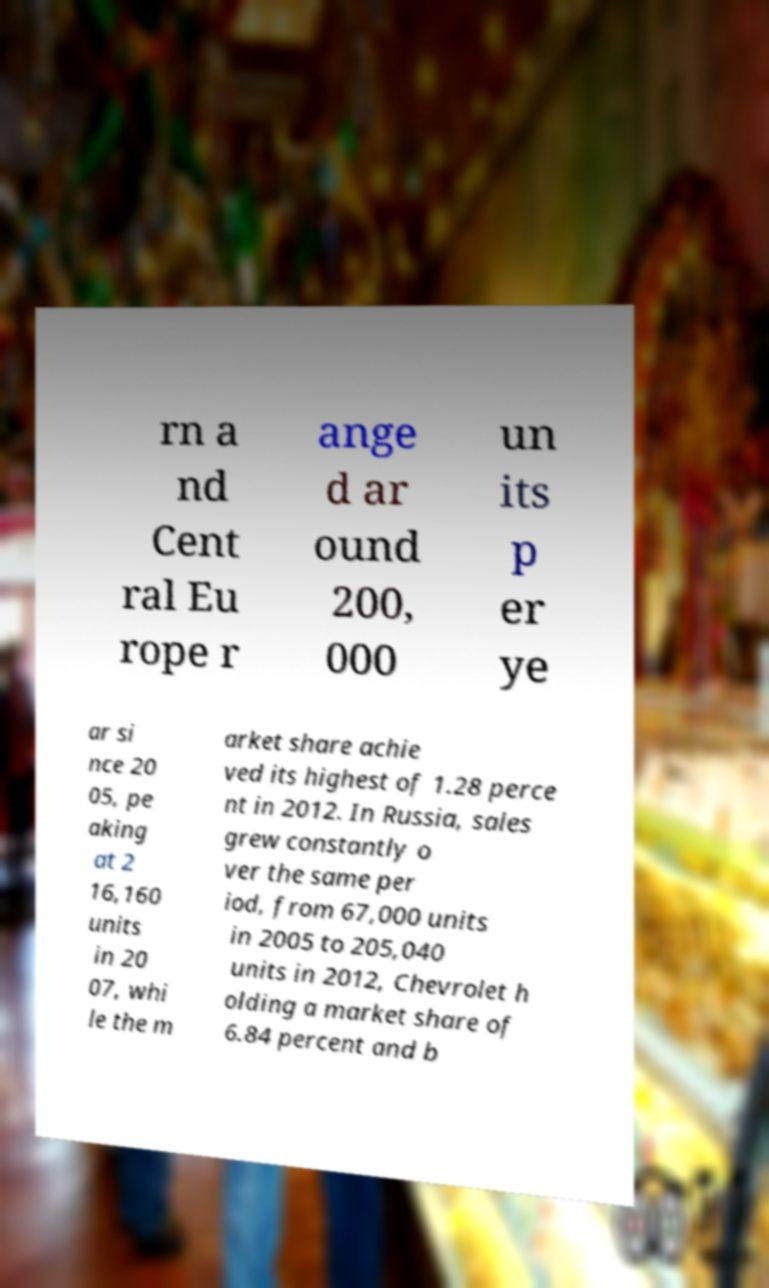Please identify and transcribe the text found in this image. rn a nd Cent ral Eu rope r ange d ar ound 200, 000 un its p er ye ar si nce 20 05, pe aking at 2 16,160 units in 20 07, whi le the m arket share achie ved its highest of 1.28 perce nt in 2012. In Russia, sales grew constantly o ver the same per iod, from 67,000 units in 2005 to 205,040 units in 2012, Chevrolet h olding a market share of 6.84 percent and b 